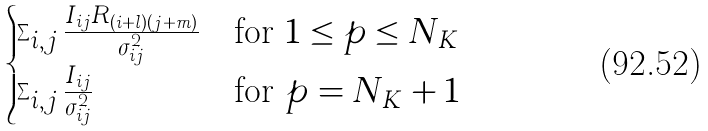<formula> <loc_0><loc_0><loc_500><loc_500>\begin{cases} \sum _ { i , j } \frac { I _ { i j } R _ { ( i + l ) ( j + m ) } } { \sigma _ { i j } ^ { 2 } } & \text {for $1 \leq p \leq N_{K}$} \\ \sum _ { i , j } \frac { I _ { i j } } { \sigma _ { i j } ^ { 2 } } & \text {for $p = N_{K} + 1$} \\ \end{cases}</formula> 